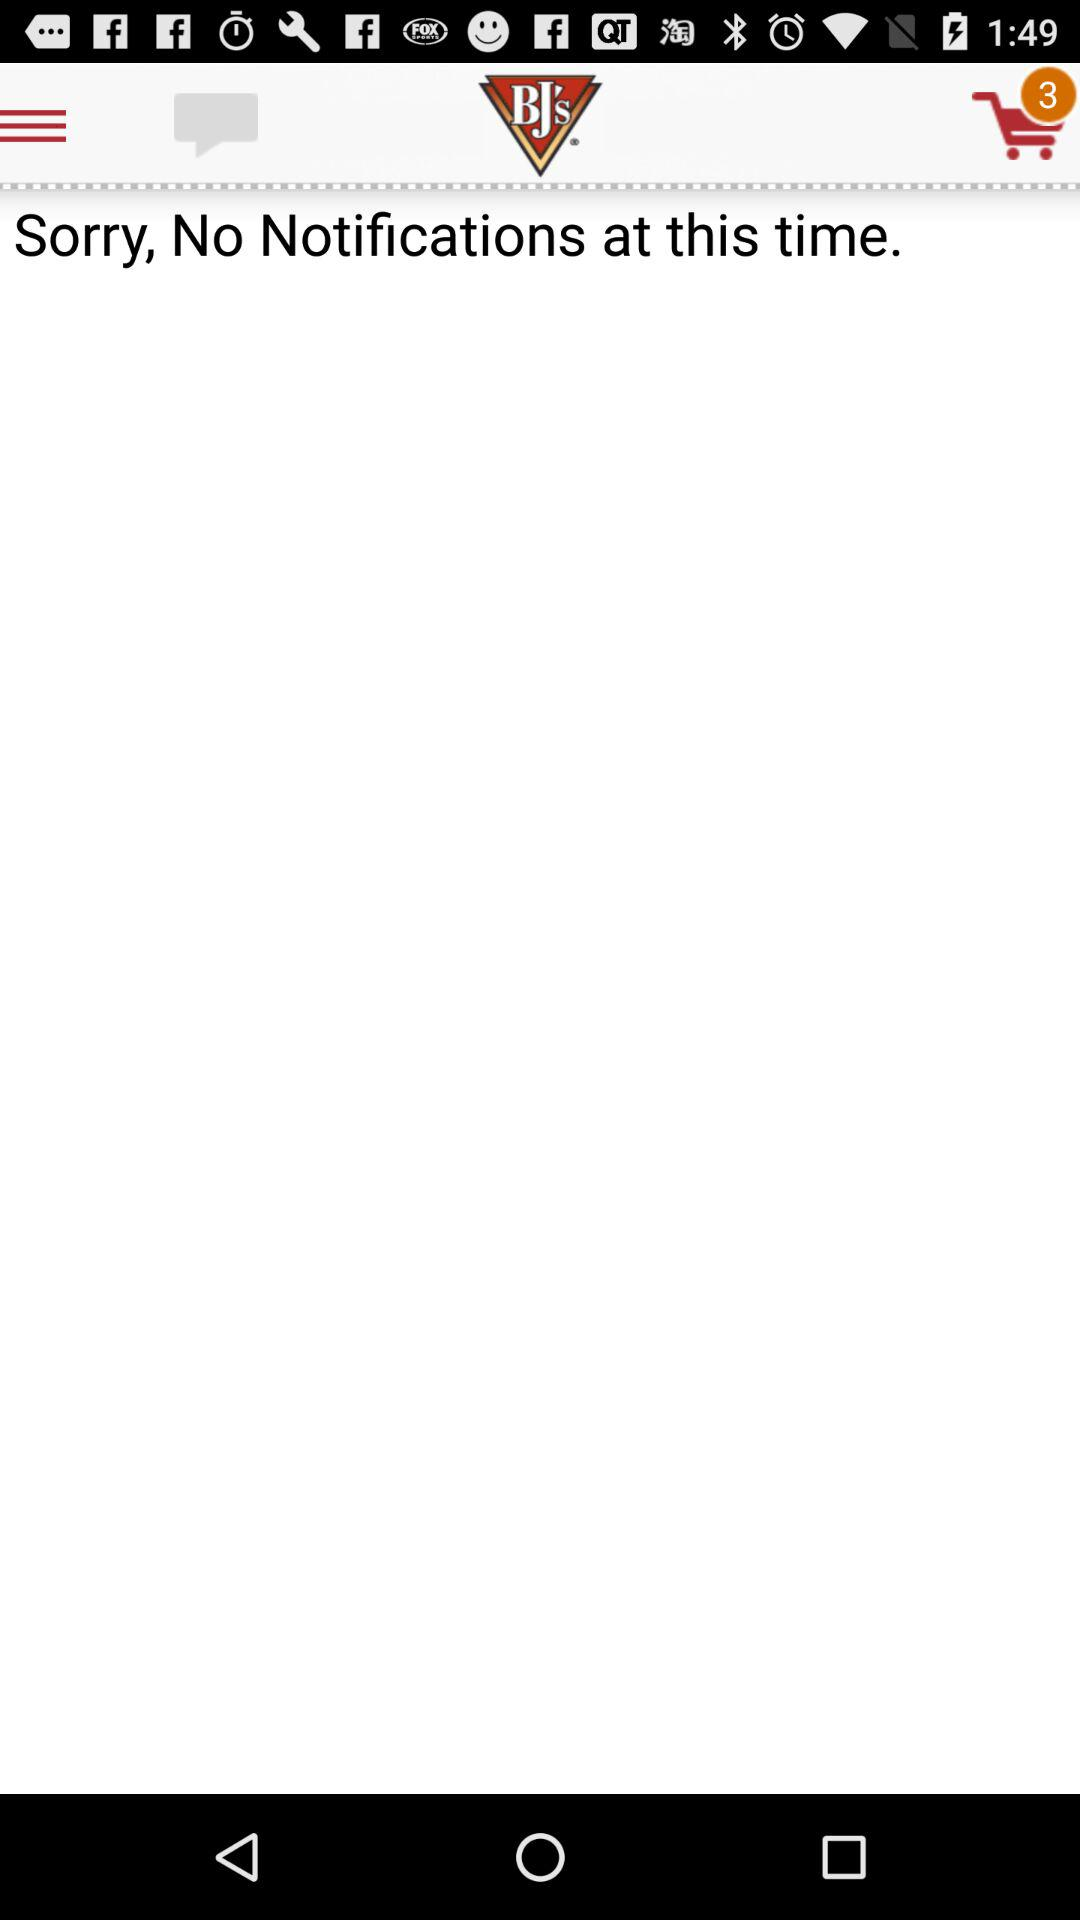How many items are there in the cart? There are three items in the cart. 